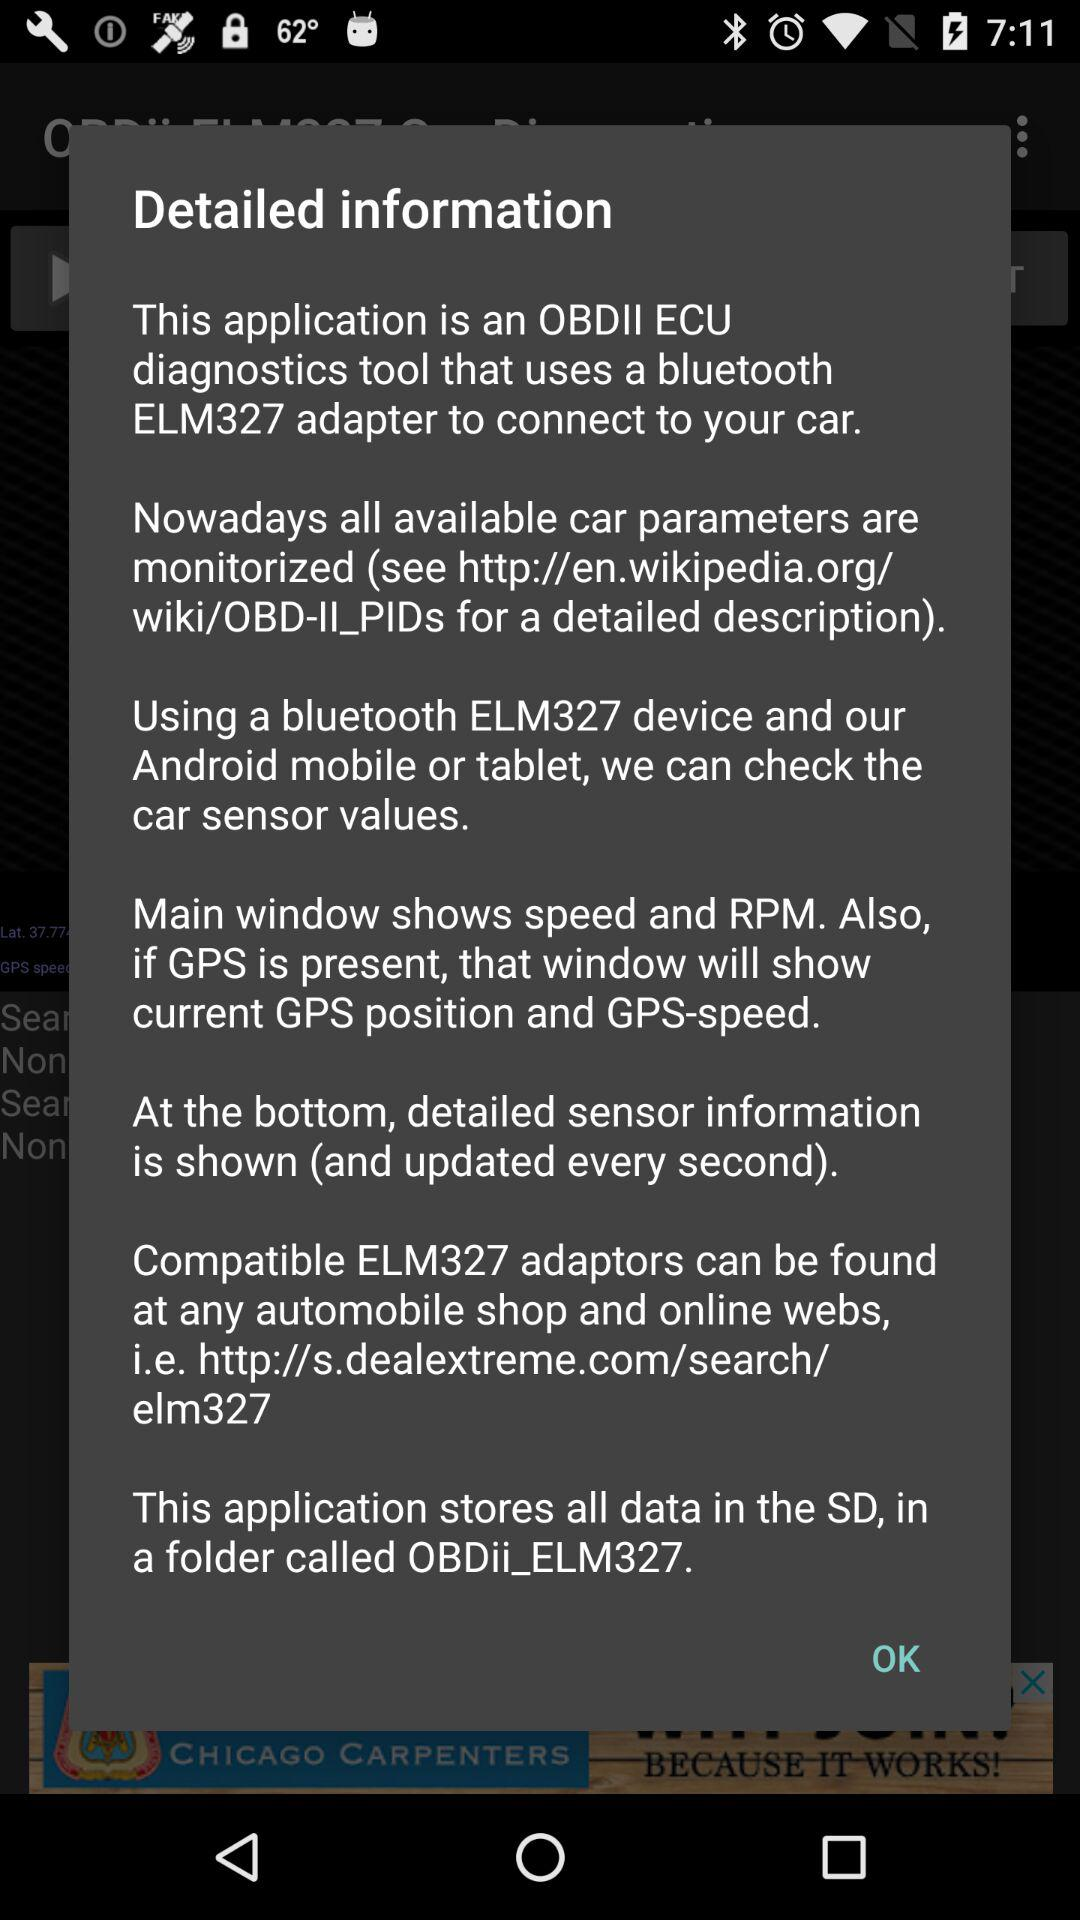What adapters can be found at any automobile shop? The compatible ELM327 adapters can be found at any automobile shop. 